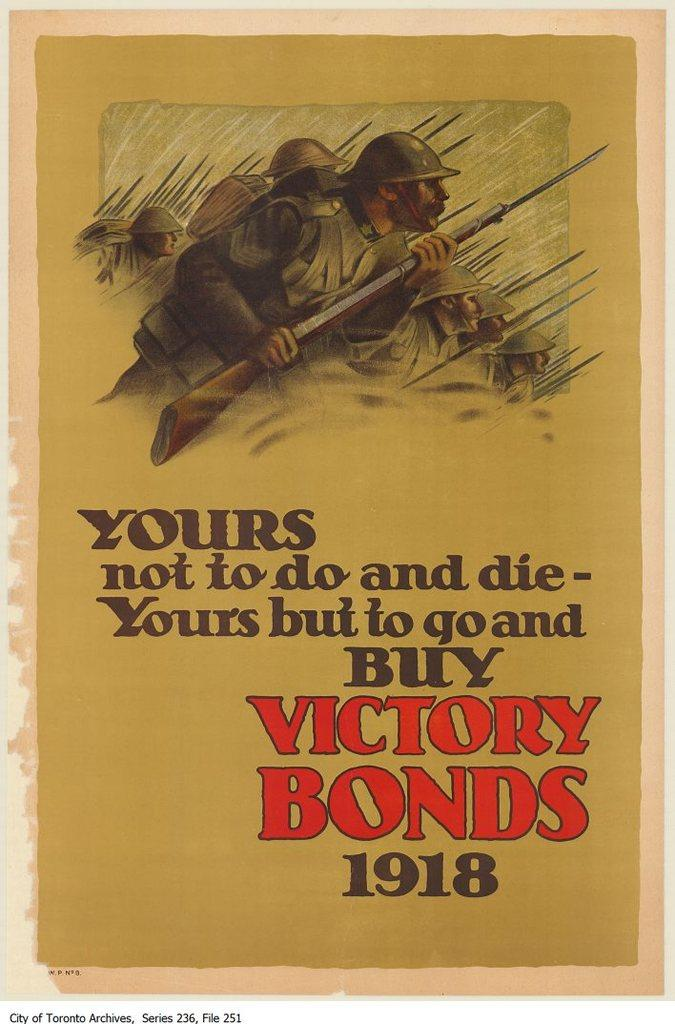<image>
Provide a brief description of the given image. A 1918 advertisement to go out and buy victory bonds. 